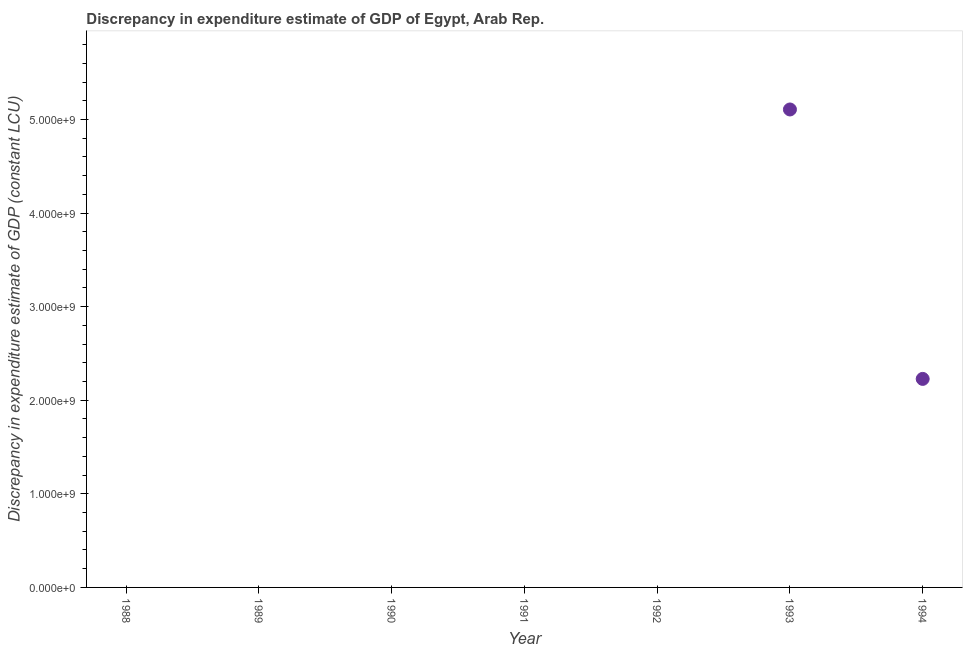What is the discrepancy in expenditure estimate of gdp in 1989?
Provide a short and direct response. 0. Across all years, what is the maximum discrepancy in expenditure estimate of gdp?
Your answer should be compact. 5.11e+09. Across all years, what is the minimum discrepancy in expenditure estimate of gdp?
Ensure brevity in your answer.  0. In which year was the discrepancy in expenditure estimate of gdp maximum?
Offer a terse response. 1993. What is the sum of the discrepancy in expenditure estimate of gdp?
Provide a succinct answer. 7.34e+09. What is the average discrepancy in expenditure estimate of gdp per year?
Provide a short and direct response. 1.05e+09. What is the median discrepancy in expenditure estimate of gdp?
Give a very brief answer. 0. What is the difference between the highest and the lowest discrepancy in expenditure estimate of gdp?
Your answer should be very brief. 5.11e+09. How many dotlines are there?
Make the answer very short. 1. Does the graph contain any zero values?
Offer a terse response. Yes. Does the graph contain grids?
Provide a succinct answer. No. What is the title of the graph?
Offer a terse response. Discrepancy in expenditure estimate of GDP of Egypt, Arab Rep. What is the label or title of the X-axis?
Your answer should be very brief. Year. What is the label or title of the Y-axis?
Your response must be concise. Discrepancy in expenditure estimate of GDP (constant LCU). What is the Discrepancy in expenditure estimate of GDP (constant LCU) in 1989?
Your answer should be compact. 0. What is the Discrepancy in expenditure estimate of GDP (constant LCU) in 1990?
Offer a terse response. 0. What is the Discrepancy in expenditure estimate of GDP (constant LCU) in 1993?
Provide a short and direct response. 5.11e+09. What is the Discrepancy in expenditure estimate of GDP (constant LCU) in 1994?
Provide a short and direct response. 2.23e+09. What is the difference between the Discrepancy in expenditure estimate of GDP (constant LCU) in 1993 and 1994?
Your answer should be very brief. 2.88e+09. What is the ratio of the Discrepancy in expenditure estimate of GDP (constant LCU) in 1993 to that in 1994?
Make the answer very short. 2.29. 